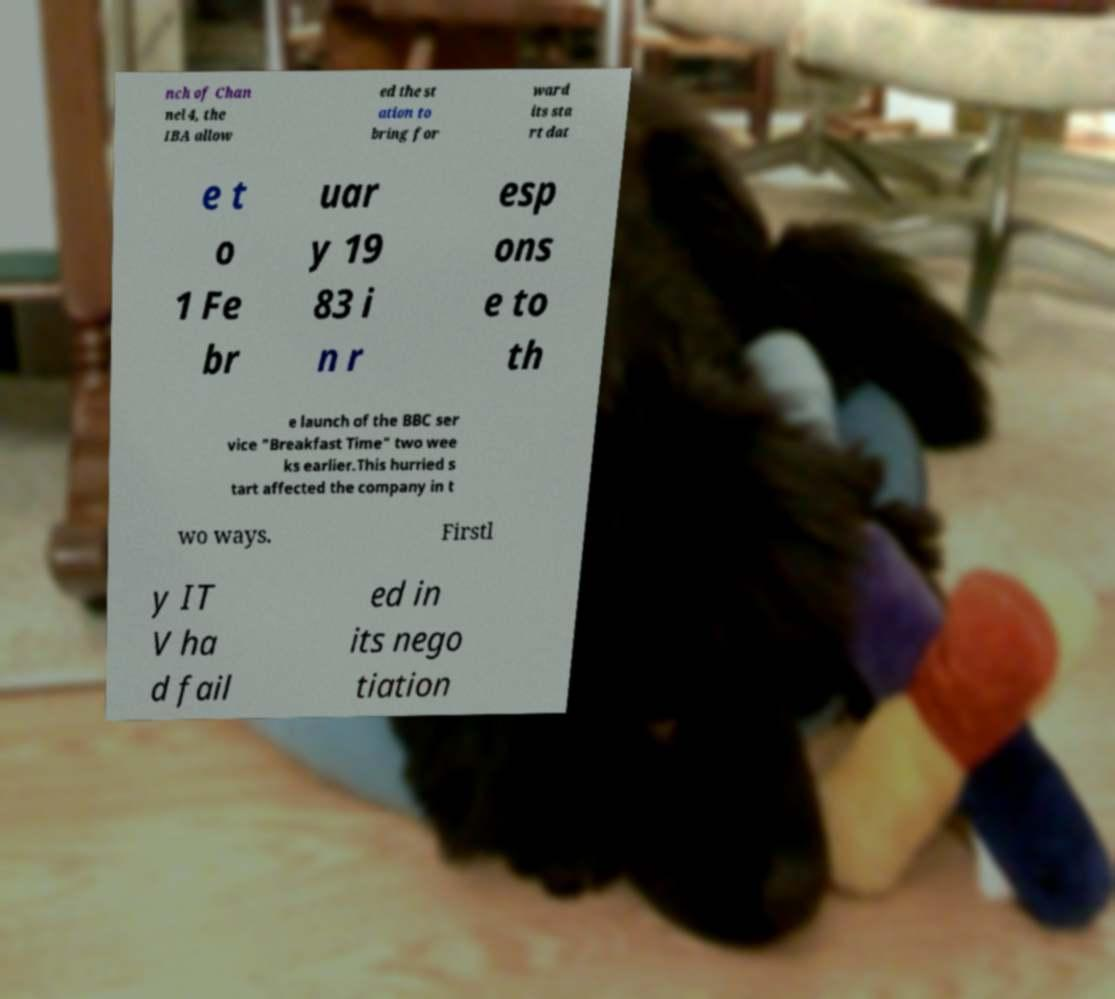What messages or text are displayed in this image? I need them in a readable, typed format. nch of Chan nel 4, the IBA allow ed the st ation to bring for ward its sta rt dat e t o 1 Fe br uar y 19 83 i n r esp ons e to th e launch of the BBC ser vice "Breakfast Time" two wee ks earlier.This hurried s tart affected the company in t wo ways. Firstl y IT V ha d fail ed in its nego tiation 